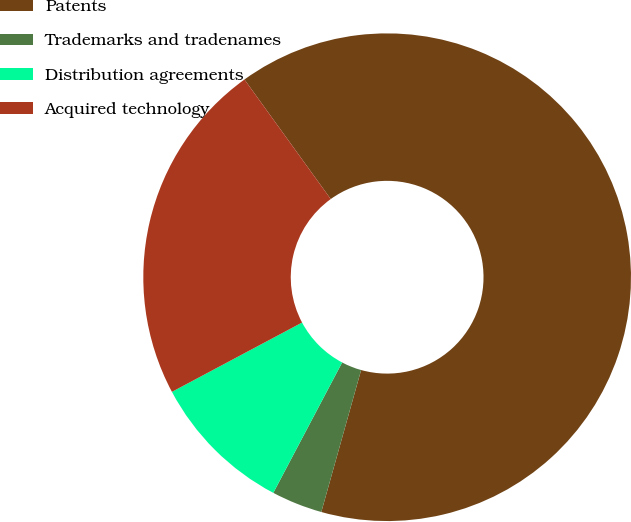Convert chart. <chart><loc_0><loc_0><loc_500><loc_500><pie_chart><fcel>Patents<fcel>Trademarks and tradenames<fcel>Distribution agreements<fcel>Acquired technology<nl><fcel>64.3%<fcel>3.38%<fcel>9.48%<fcel>22.84%<nl></chart> 